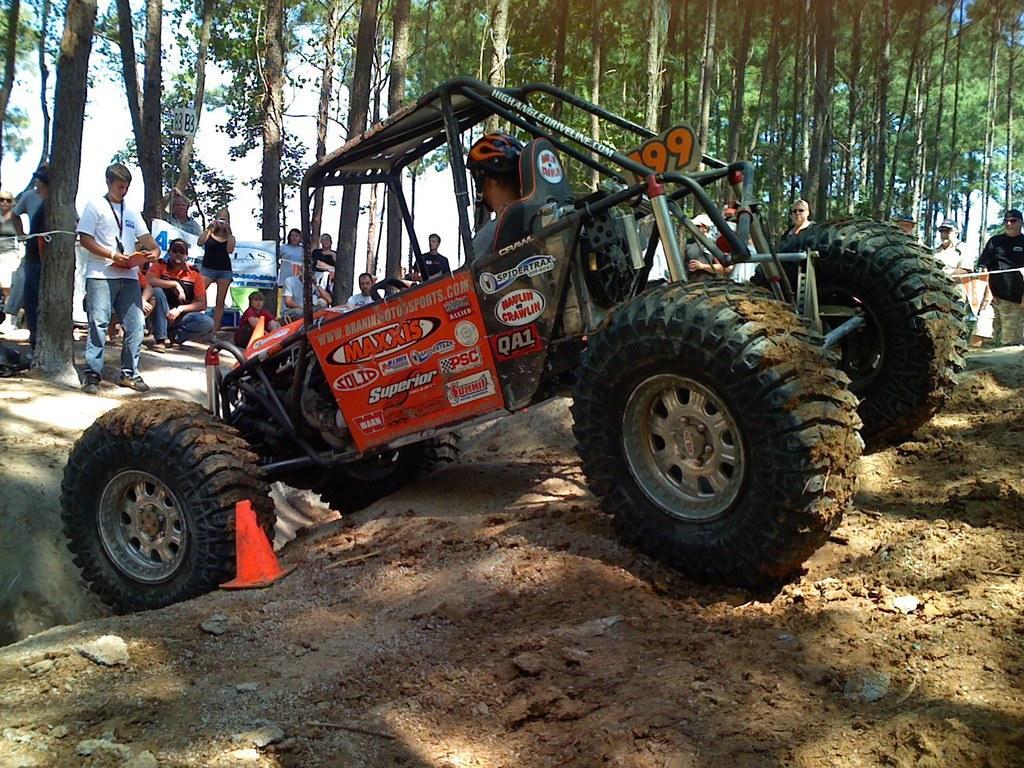How would you summarize this image in a sentence or two? In this image a vehicle is on the land. A person wearing a helmet is sitting in the vehicle. Left side there are few persons standing and few persons are sitting on the land. A person wearing a white shirt is holding book in his hand. A woman wearing a black top is holding camera in her hand. Behind the vehicle there are few persons standing on the land. In background there are few trees. 